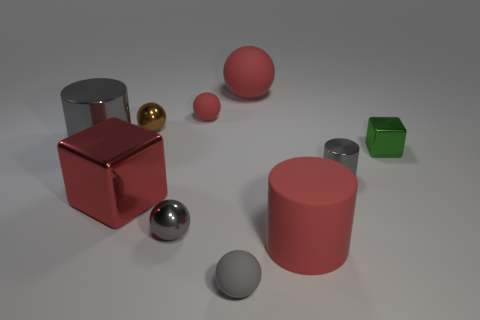There is a gray thing that is the same size as the red metal thing; what is its shape?
Provide a succinct answer. Cylinder. There is a large object that is the same color as the tiny cylinder; what is its shape?
Offer a very short reply. Cylinder. Are there an equal number of small gray cylinders that are left of the gray rubber object and purple spheres?
Your response must be concise. Yes. There is a big thing that is behind the red matte sphere that is to the left of the matte ball that is in front of the big gray shiny object; what is its material?
Give a very brief answer. Rubber. What is the shape of the large gray thing that is made of the same material as the green block?
Give a very brief answer. Cylinder. Is there anything else that is the same color as the large shiny block?
Your response must be concise. Yes. There is a red object in front of the shiny cube left of the green block; what number of tiny matte spheres are in front of it?
Make the answer very short. 1. How many gray objects are big metal cubes or small cylinders?
Your answer should be very brief. 1. Is the size of the green thing the same as the thing that is in front of the big red matte cylinder?
Provide a succinct answer. Yes. There is a big thing that is the same shape as the tiny red rubber object; what material is it?
Ensure brevity in your answer.  Rubber. 